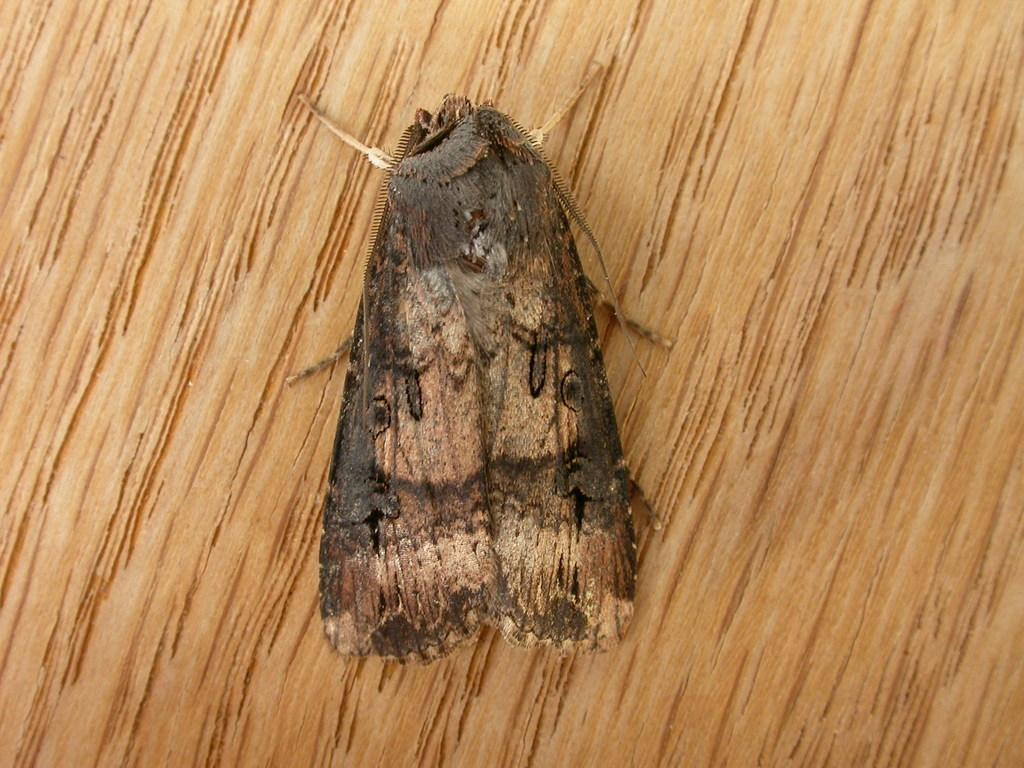What type of insect is in the image? There is a brown house moth in the image. What is the house moth resting on? The house moth is on a wooden platform. What type of farm animal can be seen in the image? There are no farm animals present in the image; it features a brown house moth on a wooden platform. What type of rifle is visible in the image? There is no rifle present in the image. 